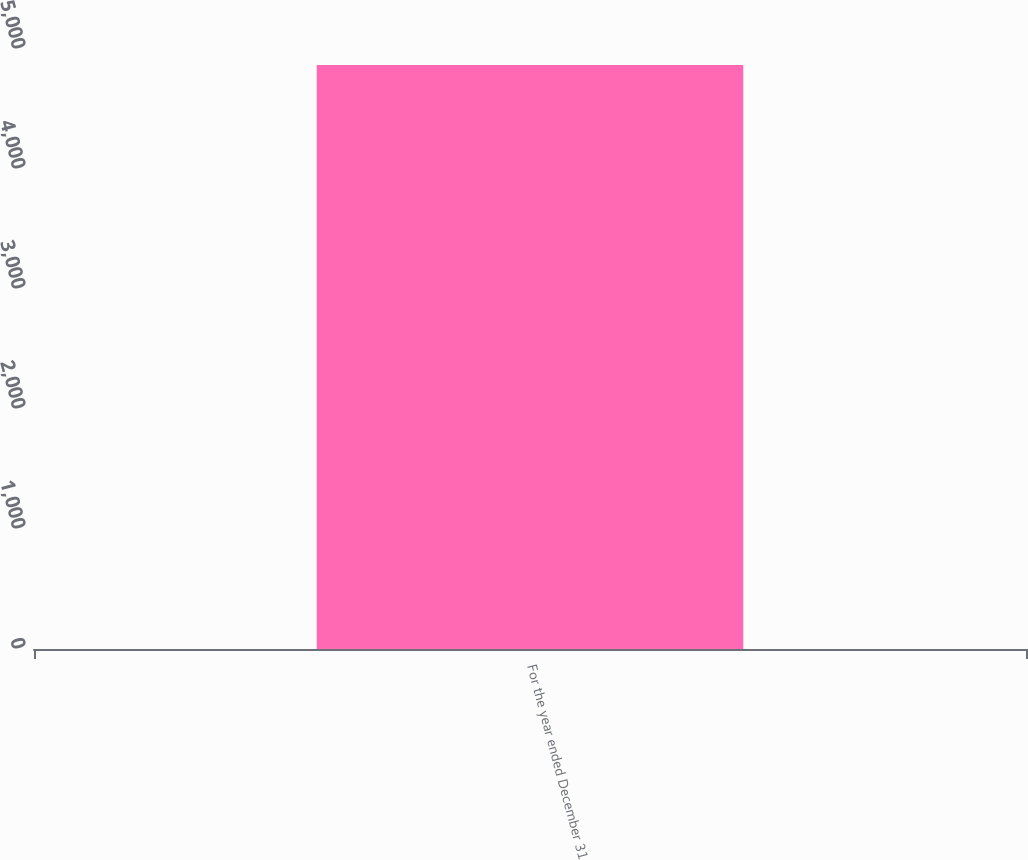<chart> <loc_0><loc_0><loc_500><loc_500><bar_chart><fcel>For the year ended December 31<nl><fcel>4866<nl></chart> 